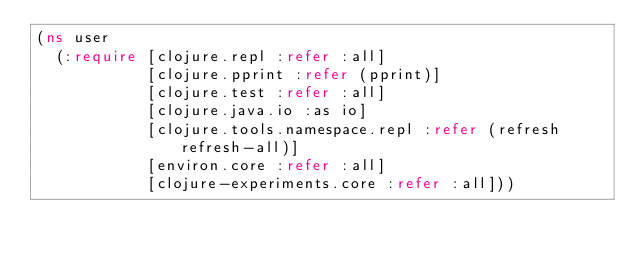<code> <loc_0><loc_0><loc_500><loc_500><_Clojure_>(ns user
  (:require [clojure.repl :refer :all]
            [clojure.pprint :refer (pprint)]
            [clojure.test :refer :all]
            [clojure.java.io :as io]
            [clojure.tools.namespace.repl :refer (refresh refresh-all)]
            [environ.core :refer :all]
            [clojure-experiments.core :refer :all]))
</code> 